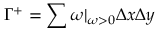Convert formula to latex. <formula><loc_0><loc_0><loc_500><loc_500>\Gamma ^ { + } = \sum \omega | _ { \omega > 0 } \Delta x \Delta y</formula> 